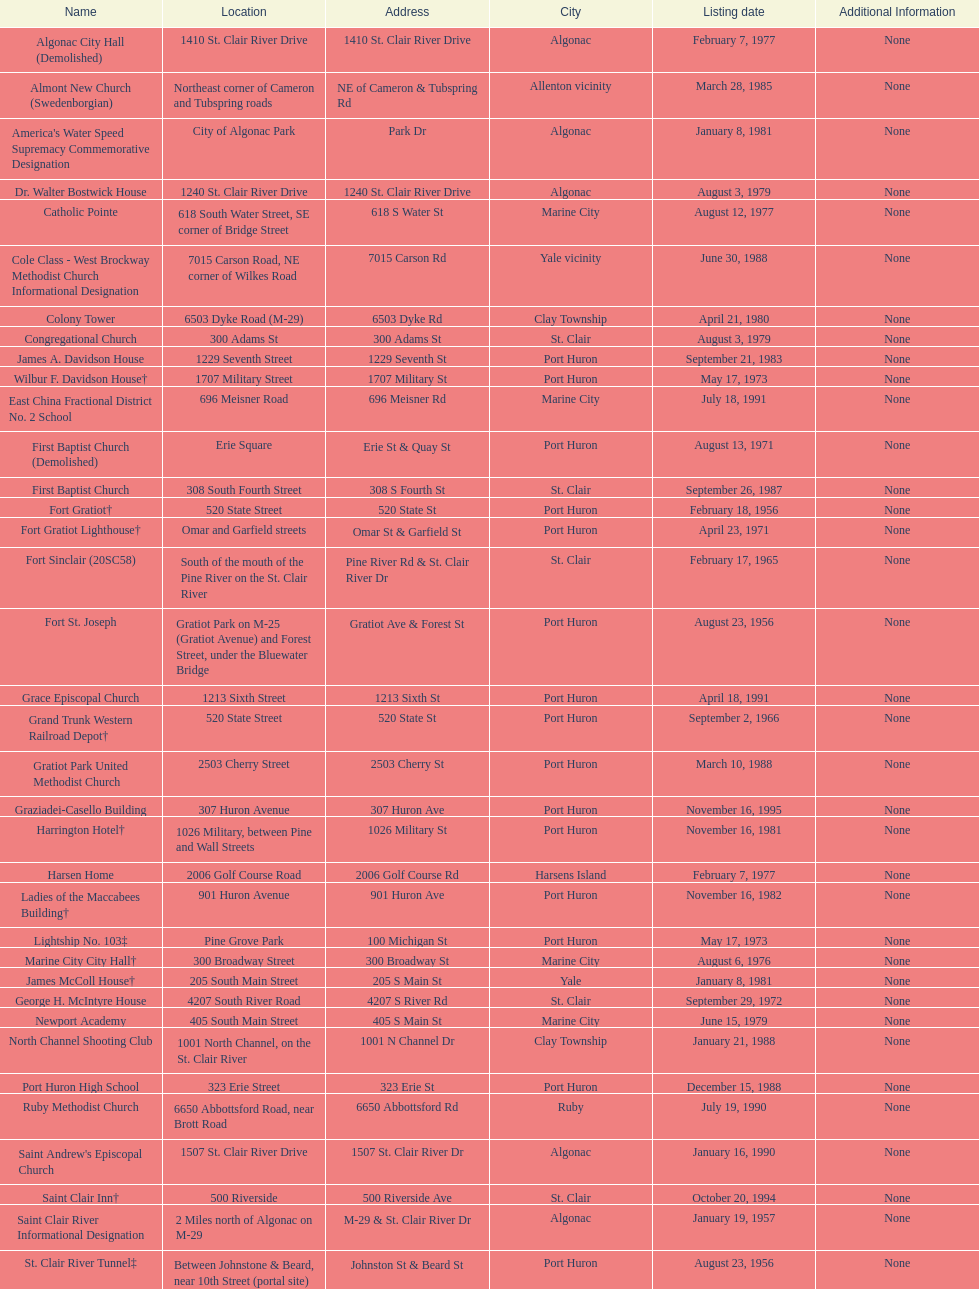How many names do not have images next to them? 41. 